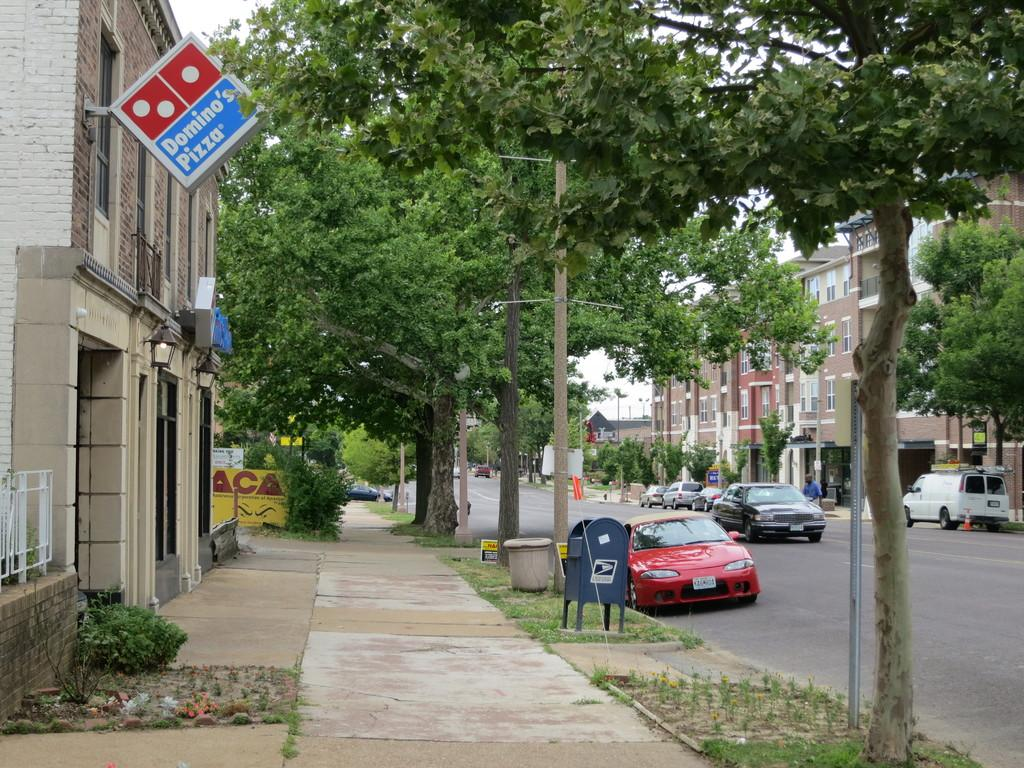What can be seen beside the road in the image? There are vehicles parked beside the road. What is located beside the footpath in the image? There are stores and buildings beside the footpath. What type of vegetation is present around the road in the image? There are many trees around the road. What type of books can be seen on the point in the image? There are no books or points present in the image; it features vehicles parked beside the road, stores and buildings beside the footpath, and trees around the road. 